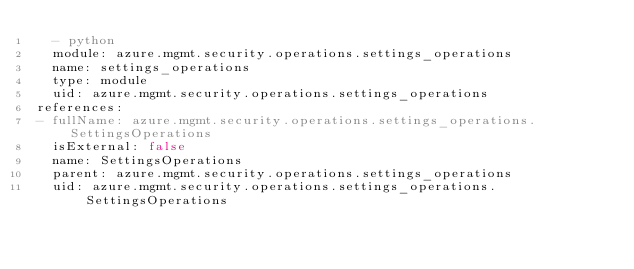<code> <loc_0><loc_0><loc_500><loc_500><_YAML_>  - python
  module: azure.mgmt.security.operations.settings_operations
  name: settings_operations
  type: module
  uid: azure.mgmt.security.operations.settings_operations
references:
- fullName: azure.mgmt.security.operations.settings_operations.SettingsOperations
  isExternal: false
  name: SettingsOperations
  parent: azure.mgmt.security.operations.settings_operations
  uid: azure.mgmt.security.operations.settings_operations.SettingsOperations
</code> 